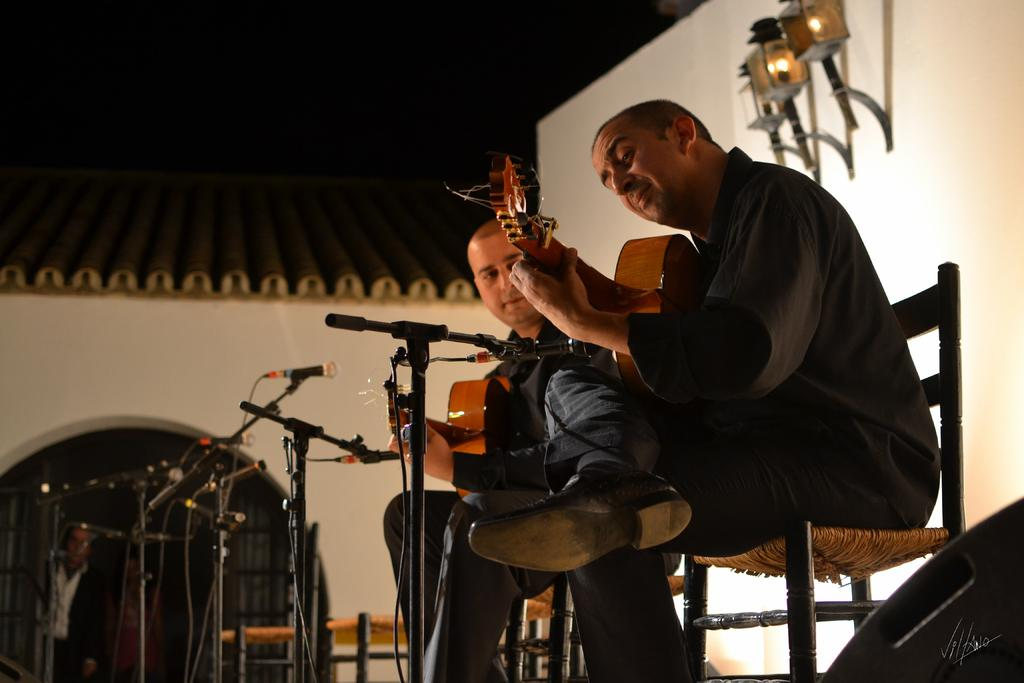What is the main subject of the image? The main subject of the image is men. What are the men doing in the image? The men are sitting in the image. What objects are the men holding in their hands? The men are holding guitars in their hands. What invention can be seen in the hands of the men in the image? There is no invention present in the image; the men are holding guitars. Is there a crib visible in the image? There is no crib present in the image. 